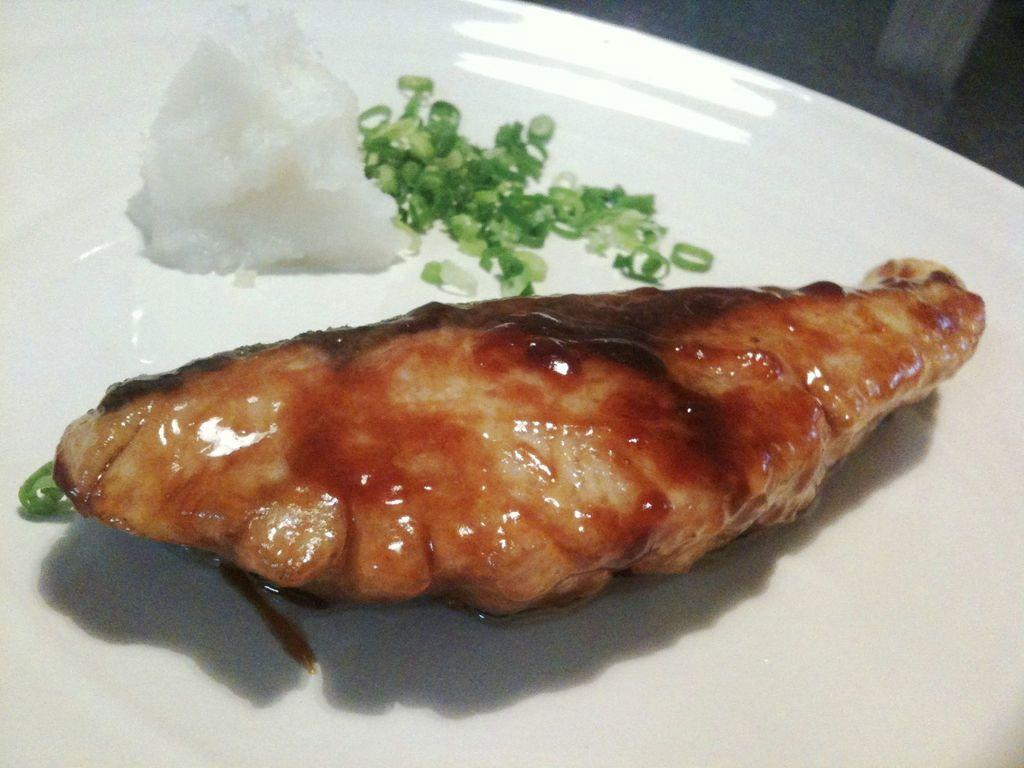What can be seen in the image related to food? There are food items in the image. How are the food items arranged or presented? The food items are kept on a plate. Is there an island in the image where the food items are being prepared? There is no island present in the image, and the food items are already on a plate, so they are not being prepared. 